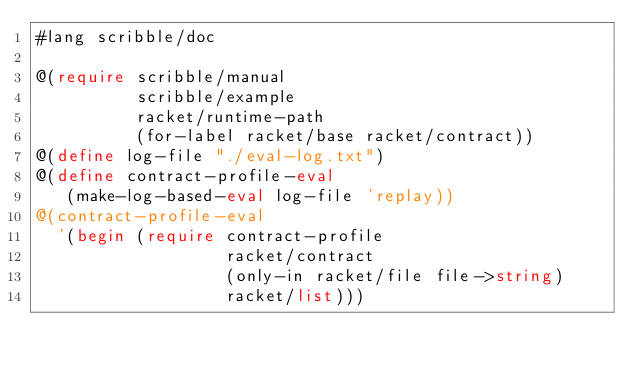<code> <loc_0><loc_0><loc_500><loc_500><_Racket_>#lang scribble/doc

@(require scribble/manual
          scribble/example
          racket/runtime-path
          (for-label racket/base racket/contract))
@(define log-file "./eval-log.txt")
@(define contract-profile-eval
   (make-log-based-eval log-file 'replay))
@(contract-profile-eval
  '(begin (require contract-profile
                   racket/contract
                   (only-in racket/file file->string)
                   racket/list)))
</code> 